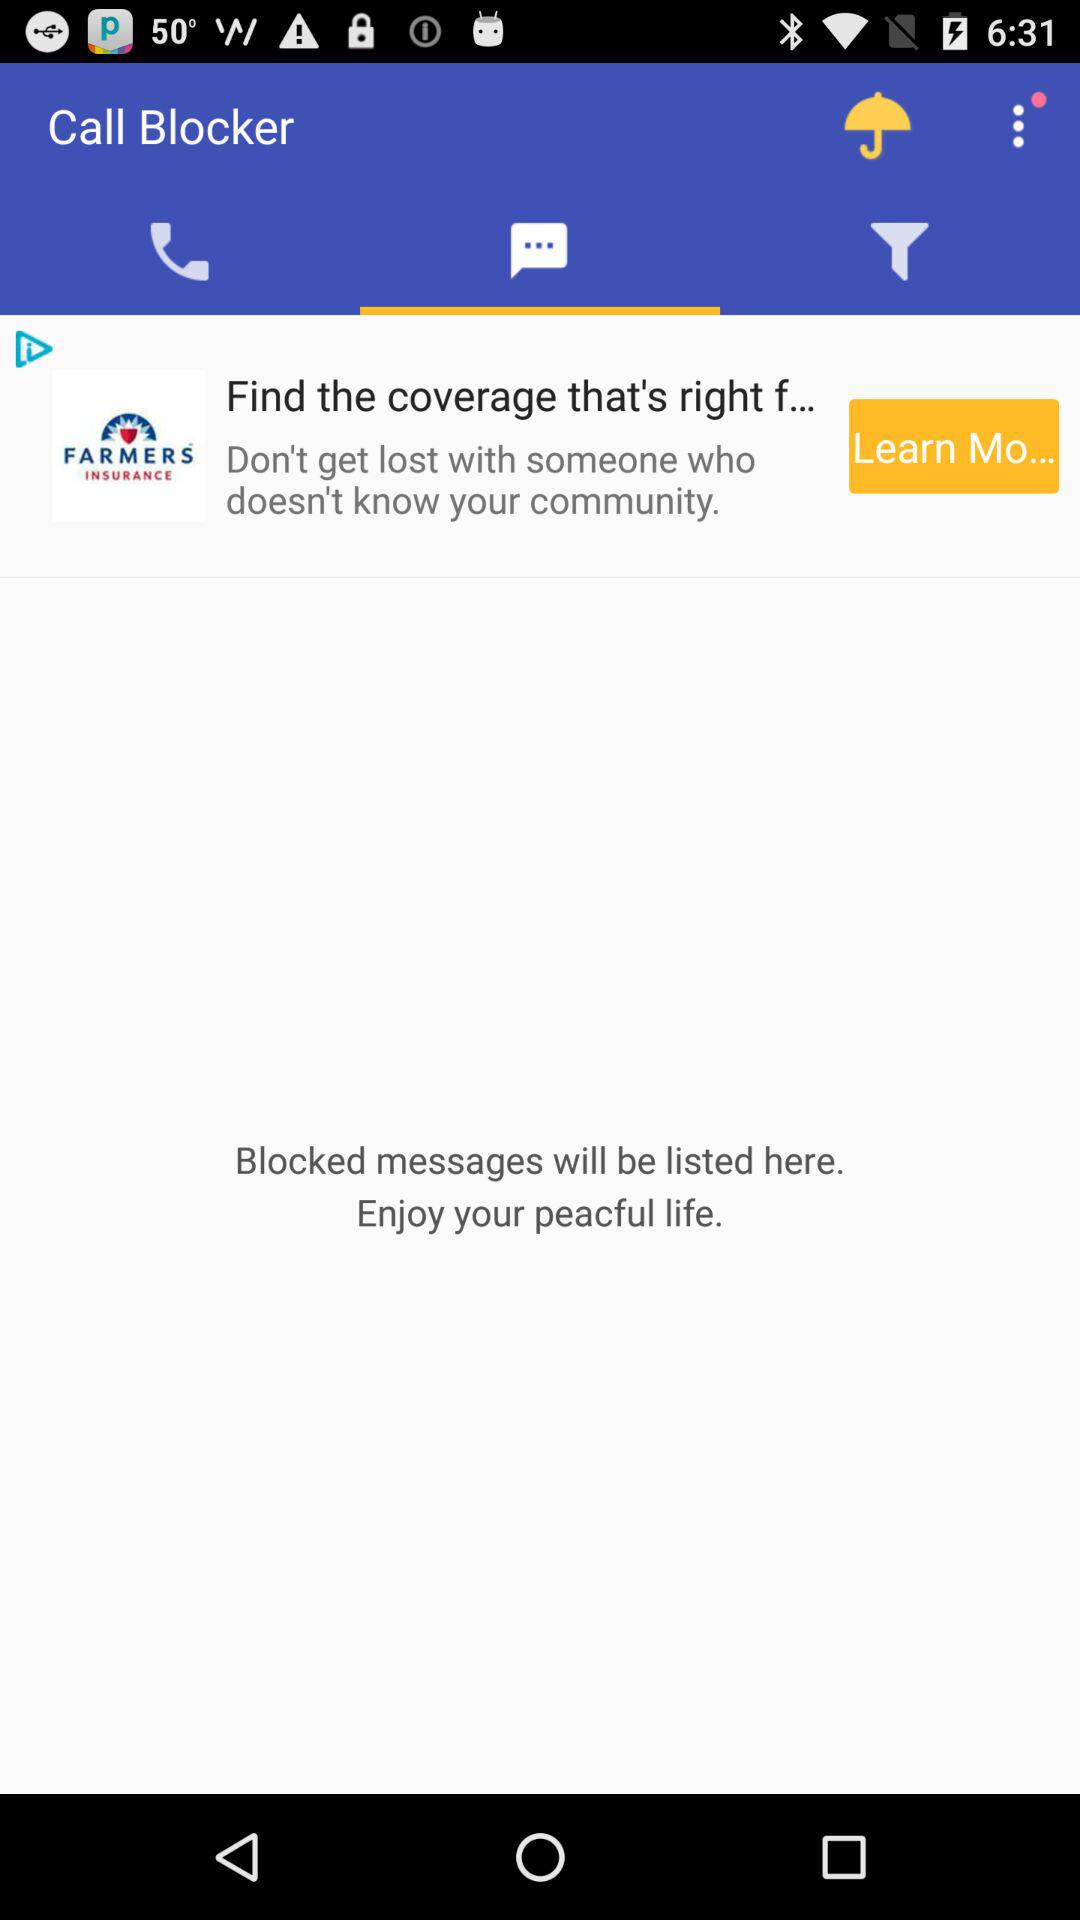What is the name of the application? The name of the application is "Call Blocker". 